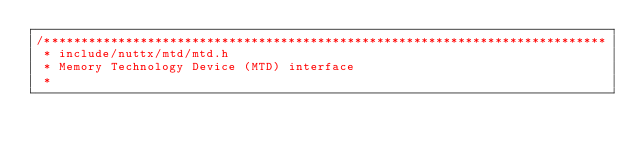<code> <loc_0><loc_0><loc_500><loc_500><_C_>/****************************************************************************
 * include/nuttx/mtd/mtd.h
 * Memory Technology Device (MTD) interface
 *</code> 